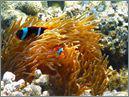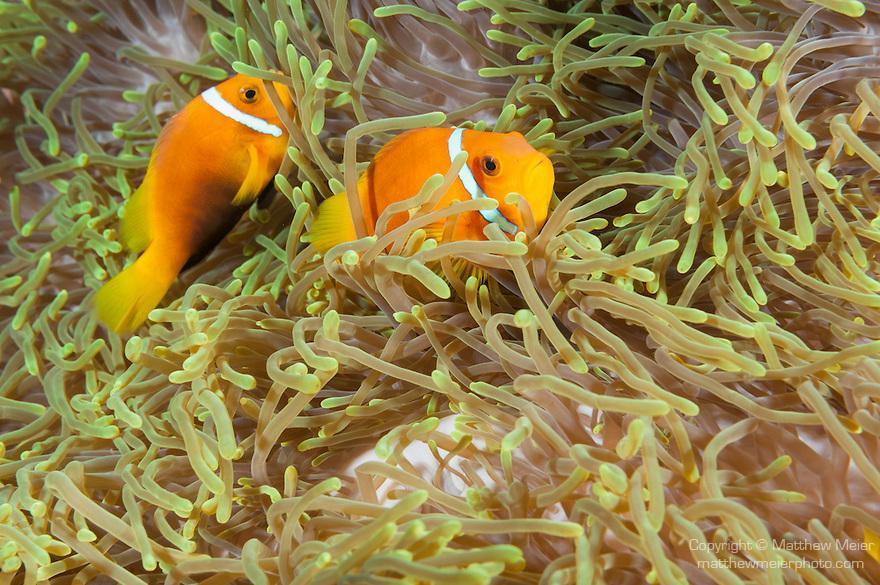The first image is the image on the left, the second image is the image on the right. Assess this claim about the two images: "There are no fish in the left image.". Correct or not? Answer yes or no. No. The first image is the image on the left, the second image is the image on the right. Analyze the images presented: Is the assertion "The left image shows clown fish swimming in the noodle-like yellowish tendrils of anemone." valid? Answer yes or no. Yes. 